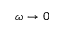<formula> <loc_0><loc_0><loc_500><loc_500>\omega \to 0</formula> 